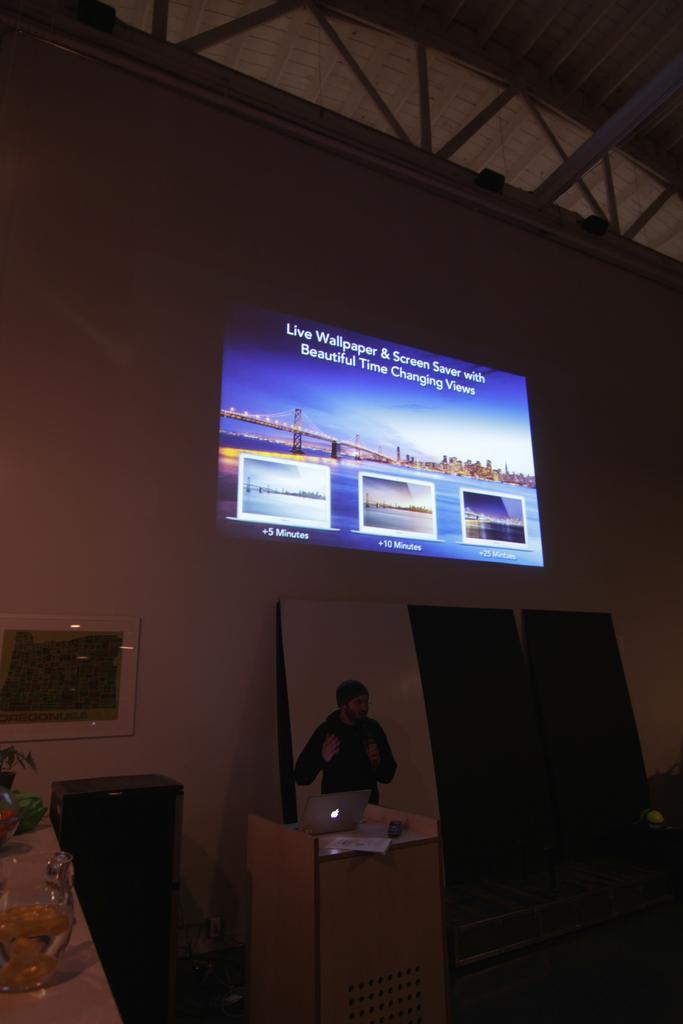How would you summarize this image in a sentence or two? In this image I can see a podium in the centre and on it I can see a laptop. I can also see one person is standing near the podium and on the left side I can see a table. On the table I can see few glass stuffs and a plant. In the background I can see a projector screen on the wall. I can also see this image is little bit blurry. 